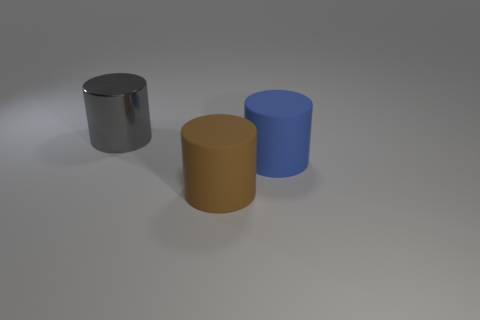Subtract 1 cylinders. How many cylinders are left? 2 Add 2 big gray balls. How many objects exist? 5 Subtract all big brown cylinders. How many cylinders are left? 2 Subtract all gray blocks. How many blue cylinders are left? 1 Subtract all brown things. Subtract all big brown rubber cylinders. How many objects are left? 1 Add 2 large gray metallic cylinders. How many large gray metallic cylinders are left? 3 Add 3 big blue metal balls. How many big blue metal balls exist? 3 Subtract all gray cylinders. How many cylinders are left? 2 Subtract 0 gray blocks. How many objects are left? 3 Subtract all red cylinders. Subtract all yellow cubes. How many cylinders are left? 3 